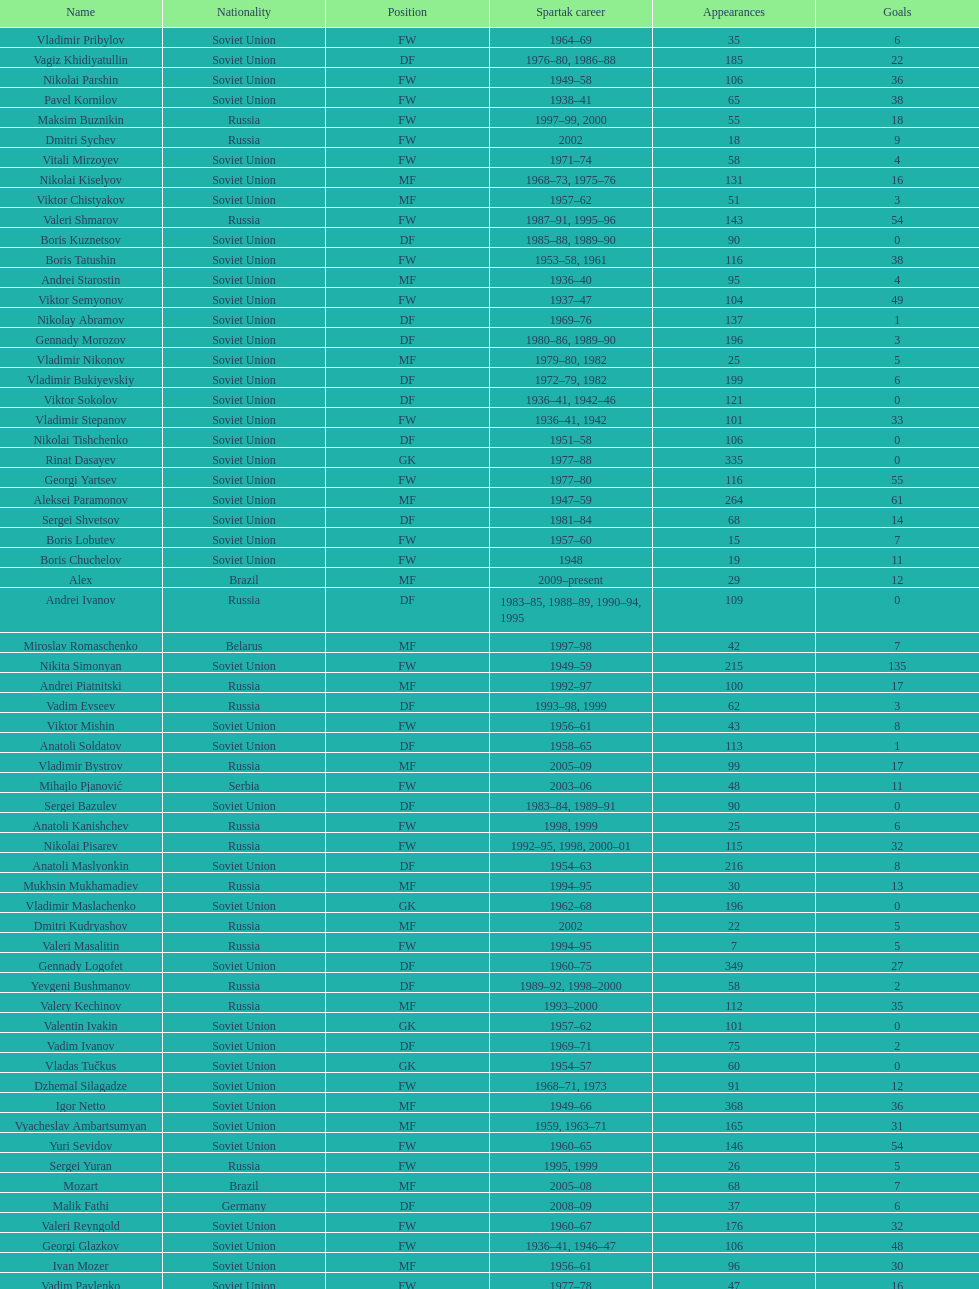Baranov has played from 2004 to the present. what is his nationality? Belarus. 